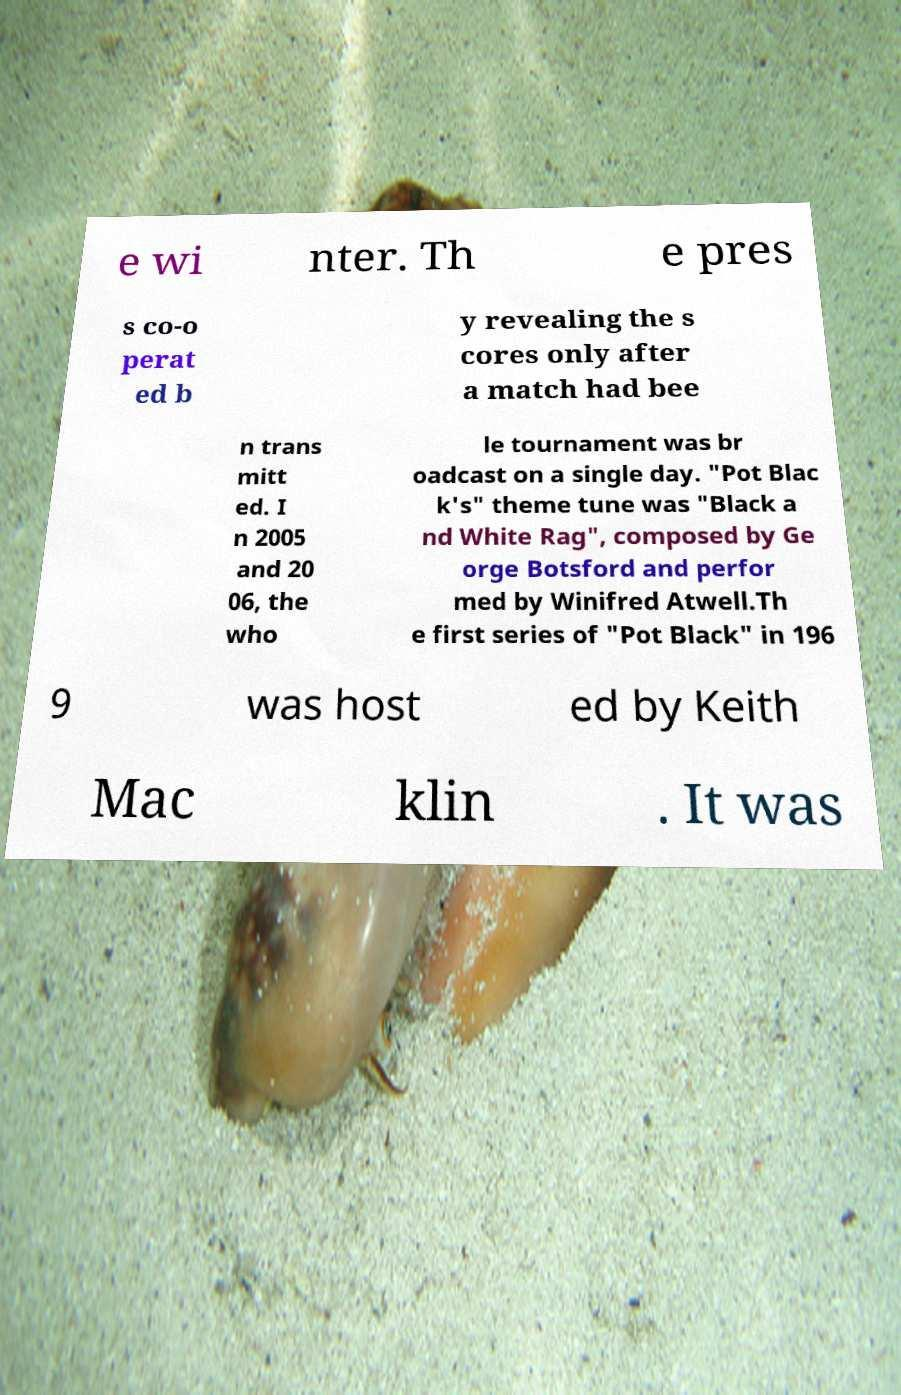Can you read and provide the text displayed in the image?This photo seems to have some interesting text. Can you extract and type it out for me? e wi nter. Th e pres s co-o perat ed b y revealing the s cores only after a match had bee n trans mitt ed. I n 2005 and 20 06, the who le tournament was br oadcast on a single day. "Pot Blac k's" theme tune was "Black a nd White Rag", composed by Ge orge Botsford and perfor med by Winifred Atwell.Th e first series of "Pot Black" in 196 9 was host ed by Keith Mac klin . It was 